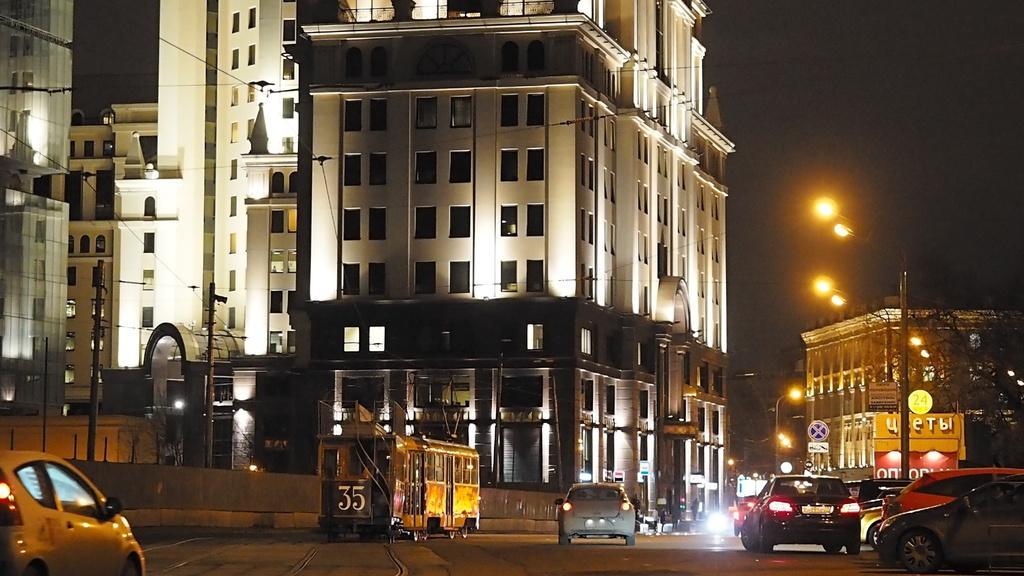Please provide a concise description of this image. In this picture I can see there are few cars moving on the road and there is a train, moving on the track. There are few buildings in the backdrop, it has few windows and there are poles with lights and there is a tree at the right side, the sky is clear and dark. 